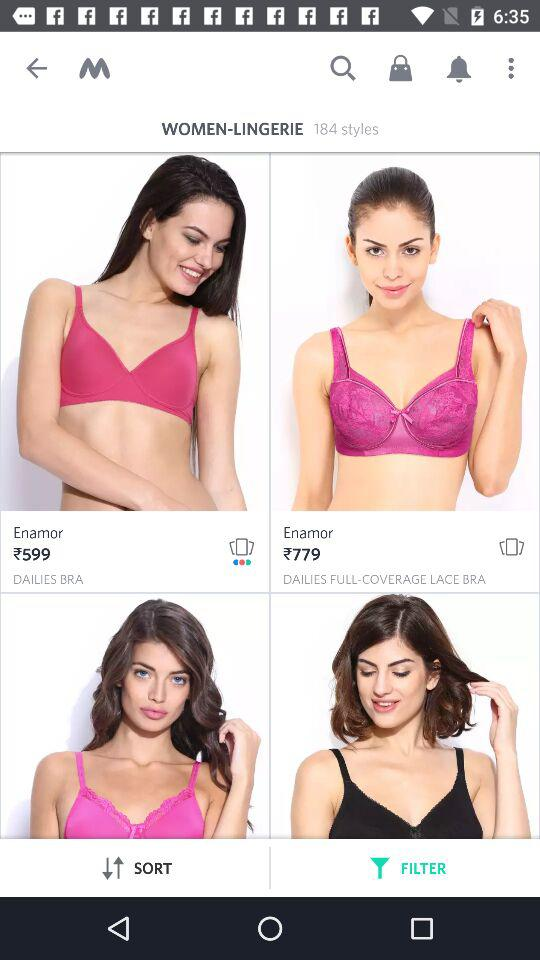What is the type of bra whose cost is 779 rupees? The type is "DAILIES FULL-COVERAGE LACE BRA". 